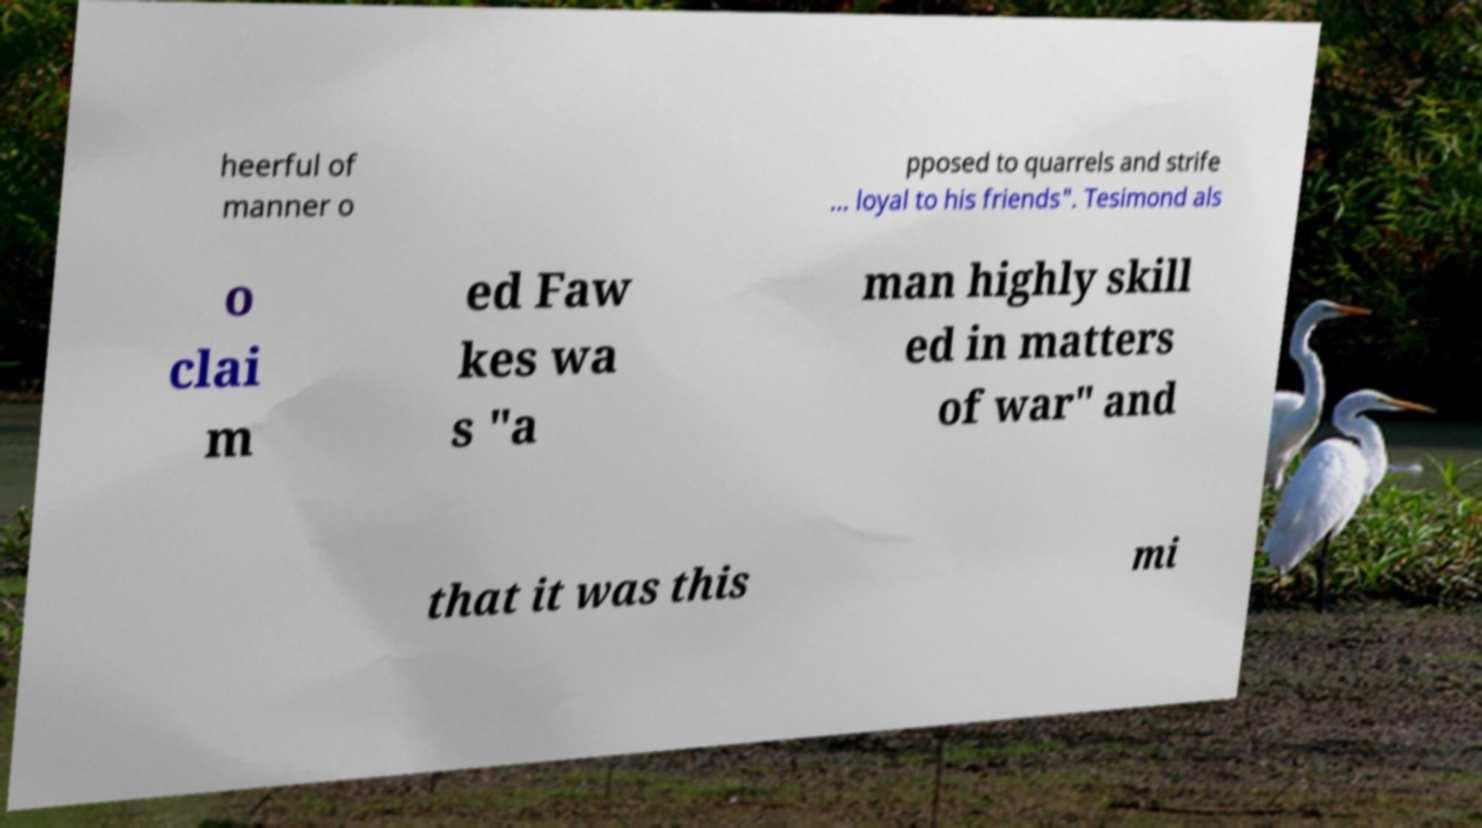I need the written content from this picture converted into text. Can you do that? heerful of manner o pposed to quarrels and strife ... loyal to his friends". Tesimond als o clai m ed Faw kes wa s "a man highly skill ed in matters of war" and that it was this mi 